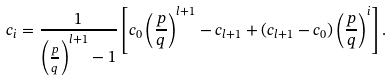<formula> <loc_0><loc_0><loc_500><loc_500>c _ { i } = \frac { 1 } { \left ( \frac { p } { q } \right ) ^ { l + 1 } - 1 } \left [ c _ { 0 } \left ( \frac { p } { q } \right ) ^ { l + 1 } - c _ { l + 1 } + ( c _ { l + 1 } - c _ { 0 } ) \left ( \frac { p } { q } \right ) ^ { i } \right ] .</formula> 